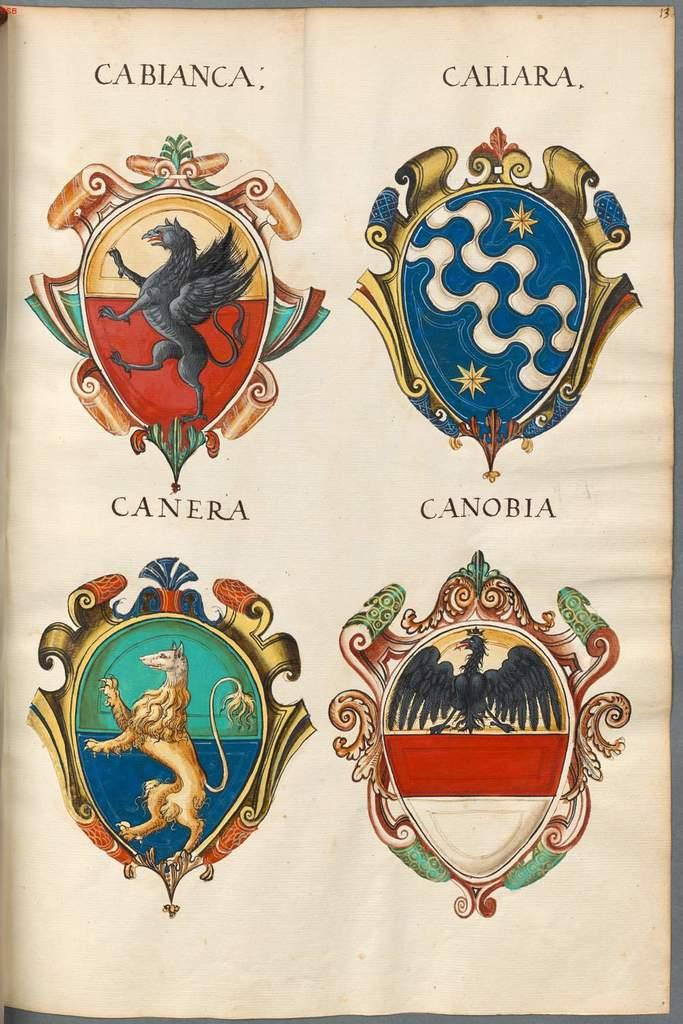What type of images can be seen on the logos in the image? The logos in the image have animal pictures. What else is present in the image besides the logos? There is text written on the image. How many books are stacked on the list in the image? There are no books or lists present in the image; it only contains logos with animal pictures and text. 